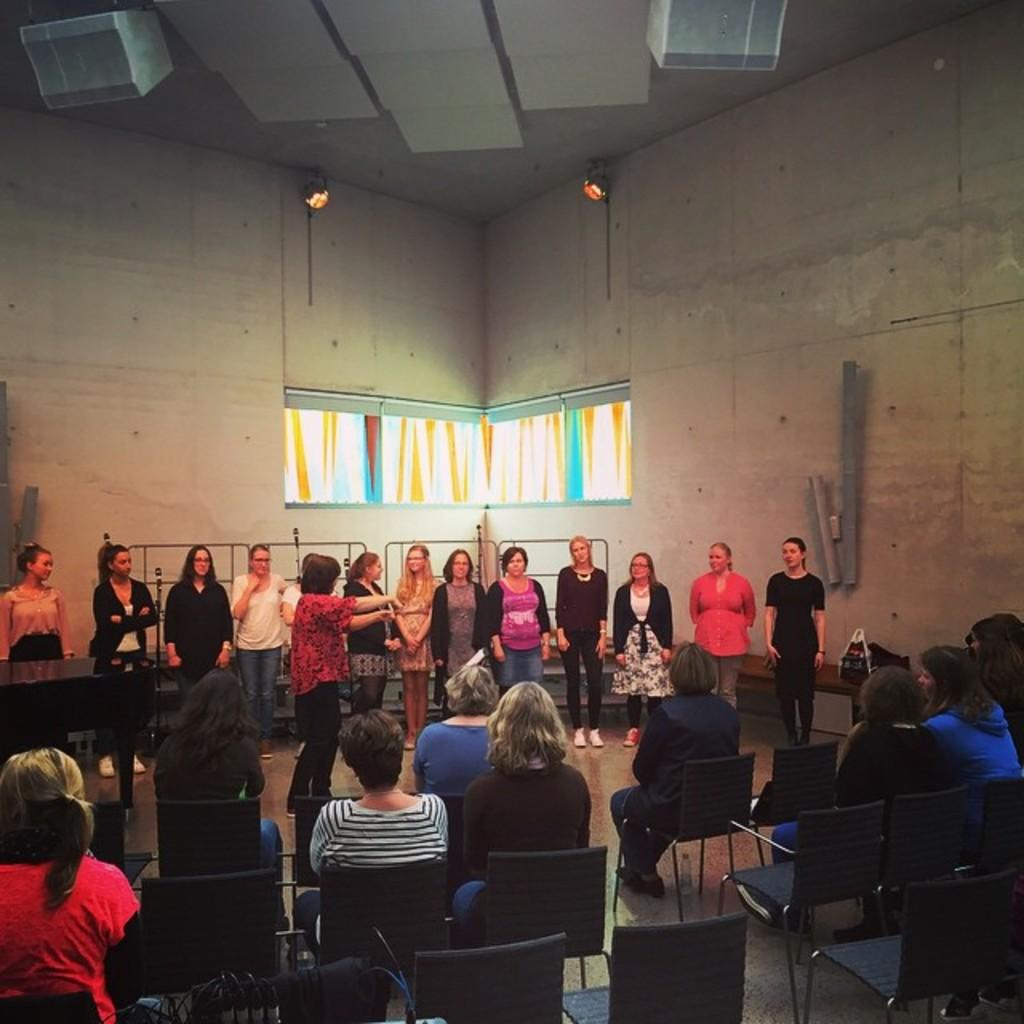What are the people in the image doing? There are people standing and sitting on chairs in the image. What can be seen on the walls in the image? There are windows visible in the image. Where are the speakers located in the image? There are two speakers at the top of the image. What is the chance of finding a tin can on the floor in the image? There is no tin can present in the image, so it is not possible to determine the chance of finding one. 